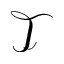Convert formula to latex. <formula><loc_0><loc_0><loc_500><loc_500>\mathcal { T }</formula> 